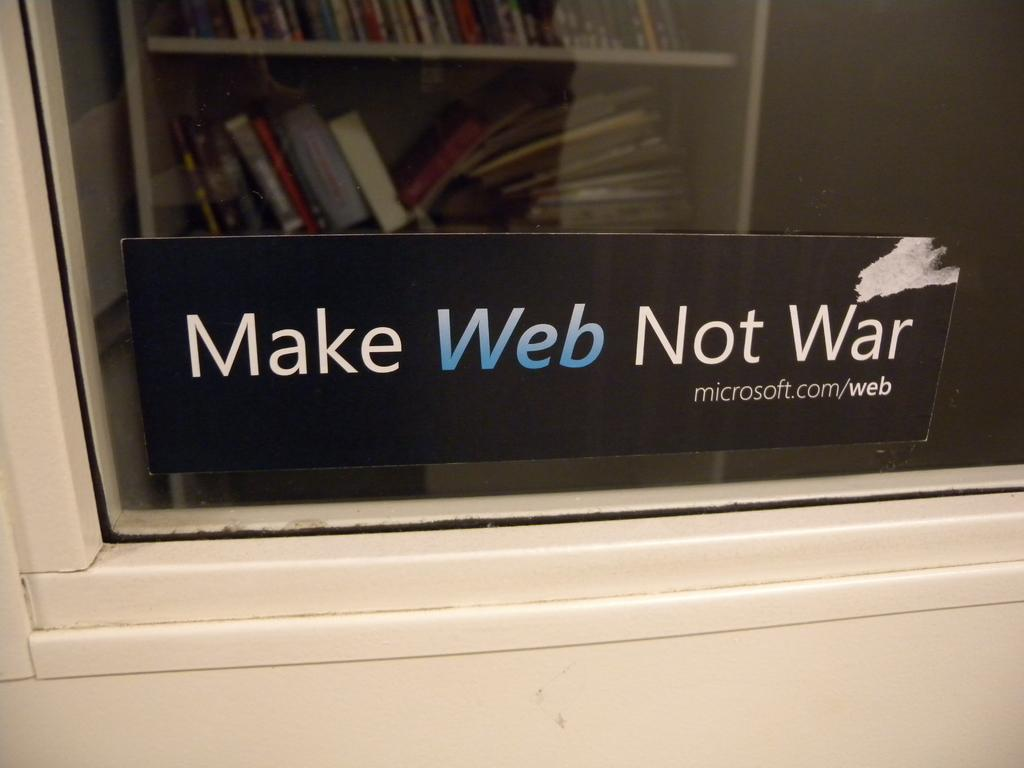<image>
Create a compact narrative representing the image presented. bookcase showing behind a window with words on it make web not war 